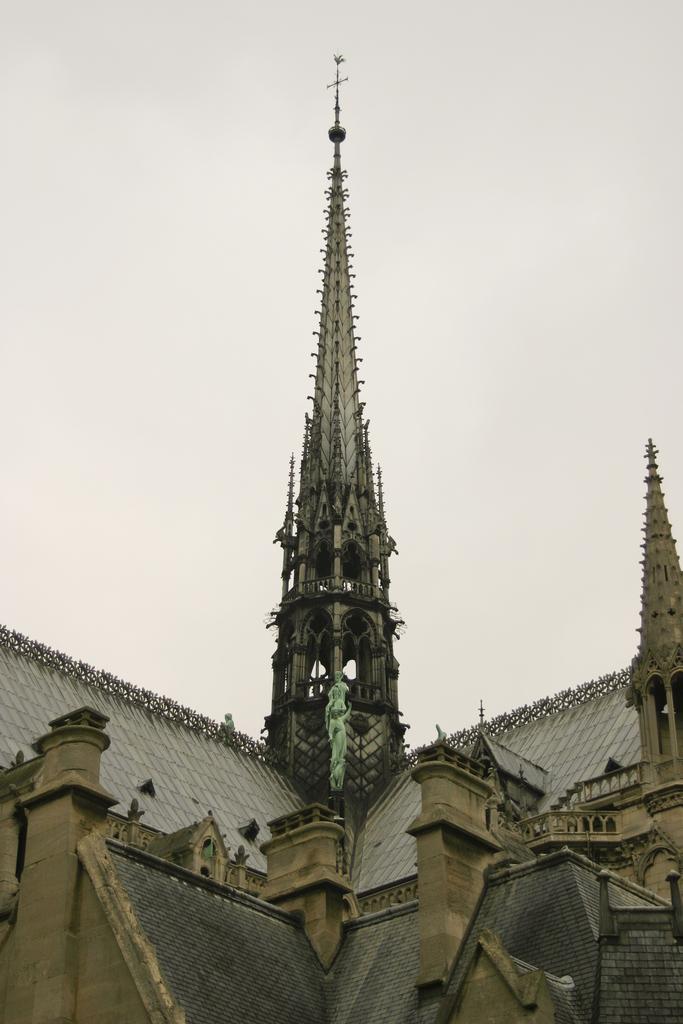Describe this image in one or two sentences. In the center of the image there is a tower. There are buildings. In the background of the image there is sky. 